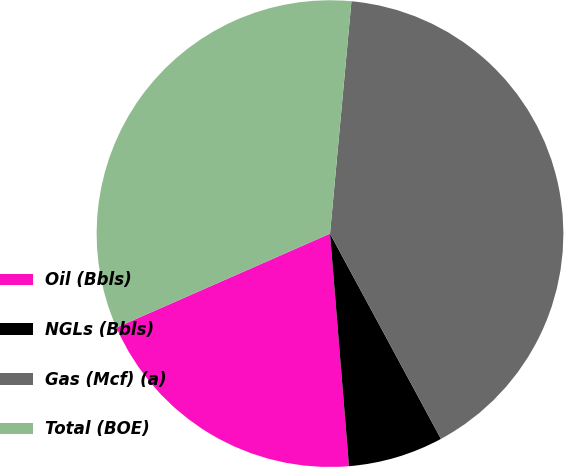Convert chart. <chart><loc_0><loc_0><loc_500><loc_500><pie_chart><fcel>Oil (Bbls)<fcel>NGLs (Bbls)<fcel>Gas (Mcf) (a)<fcel>Total (BOE)<nl><fcel>19.7%<fcel>6.59%<fcel>40.65%<fcel>33.06%<nl></chart> 